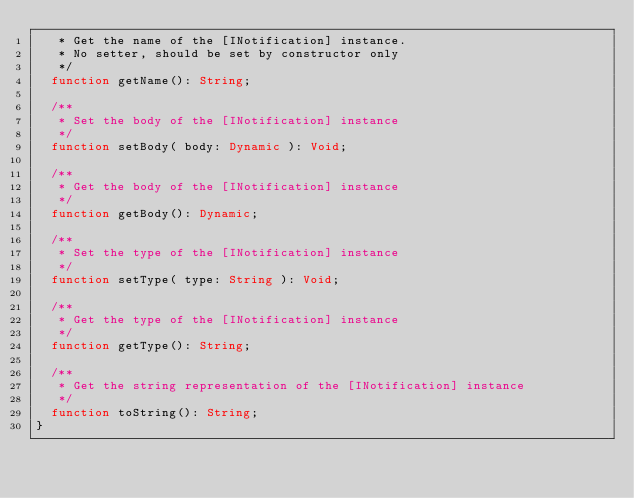Convert code to text. <code><loc_0><loc_0><loc_500><loc_500><_Haxe_>	 * Get the name of the [INotification] instance. 
	 * No setter, should be set by constructor only
	 */
	function getName(): String;

	/**
	 * Set the body of the [INotification] instance
	 */
	function setBody( body: Dynamic ): Void;
		
	/**
	 * Get the body of the [INotification] instance
	 */
	function getBody(): Dynamic;
		
	/**
	 * Set the type of the [INotification] instance
	 */
	function setType( type: String ): Void;
		
	/**
	 * Get the type of the [INotification] instance
	 */
	function getType(): String;

	/**
	 * Get the string representation of the [INotification] instance
	 */
	function toString(): String;
}</code> 